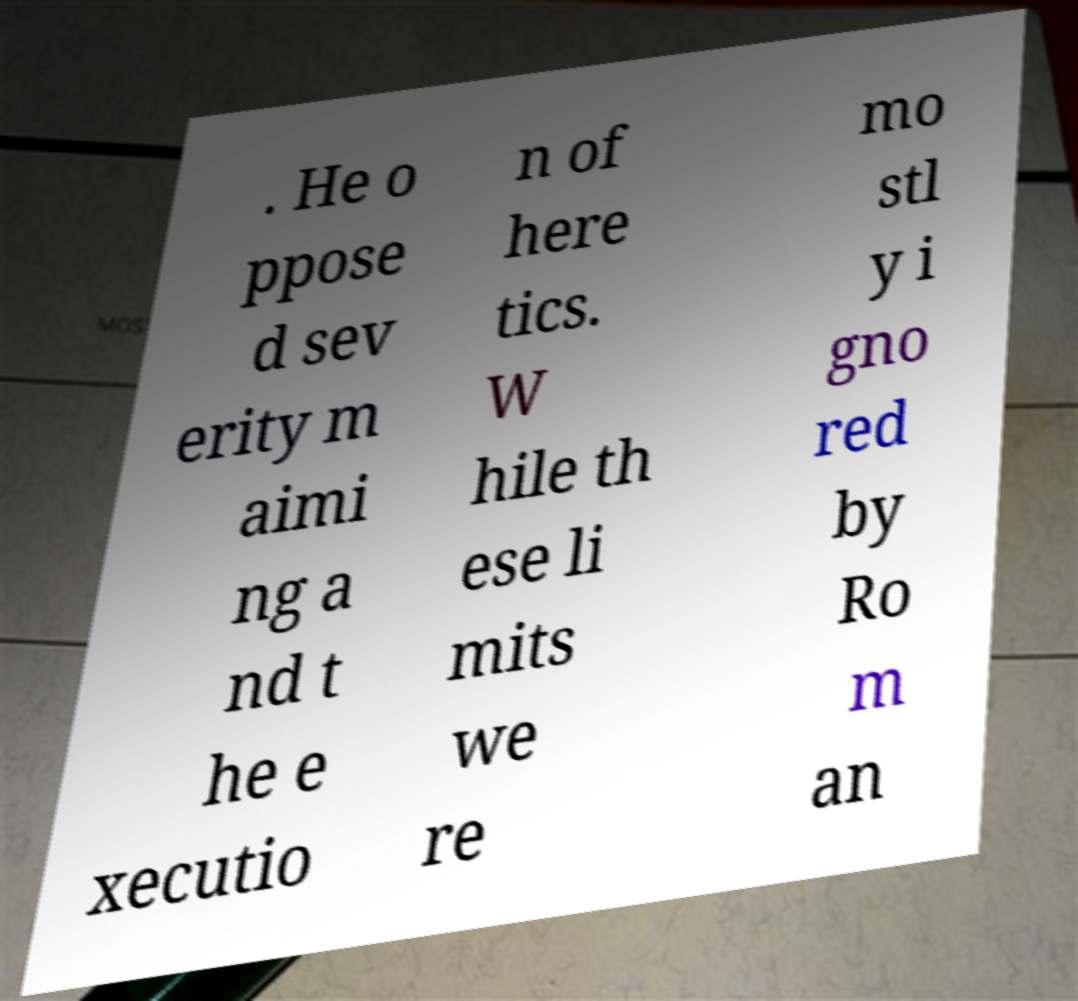There's text embedded in this image that I need extracted. Can you transcribe it verbatim? . He o ppose d sev erity m aimi ng a nd t he e xecutio n of here tics. W hile th ese li mits we re mo stl y i gno red by Ro m an 